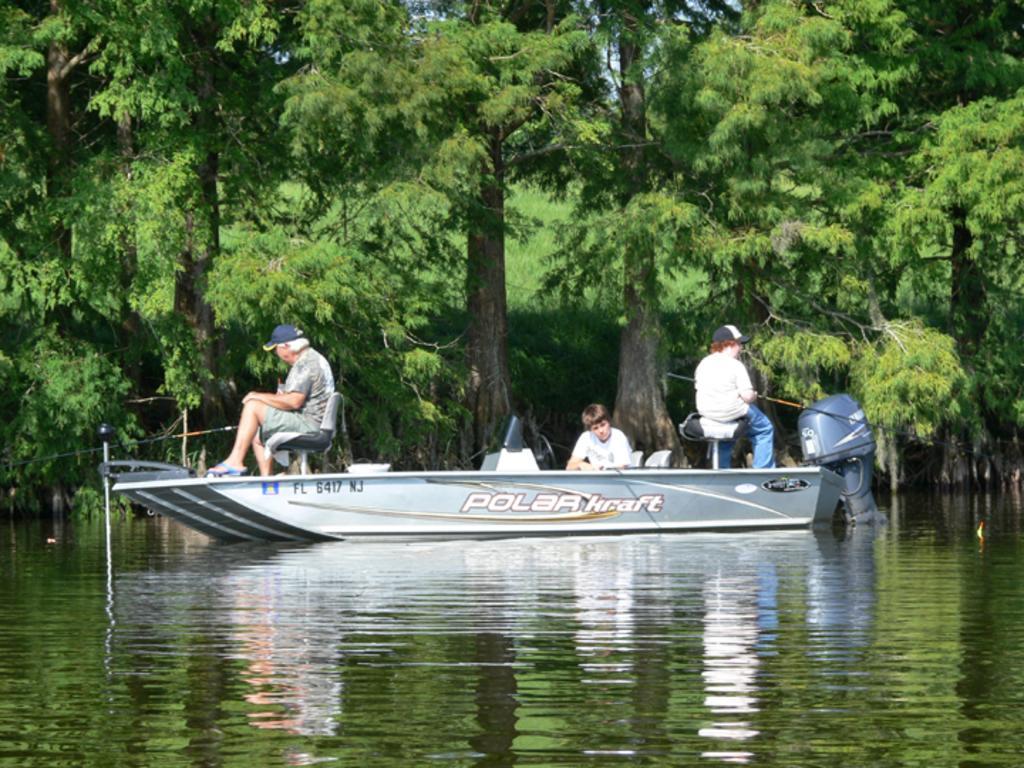In one or two sentences, can you explain what this image depicts? In this image I can see water and in it I can see a boat. I can also see few people are sitting on this boat and here I can see something is written. In the background I can see number of trees and I can see few people are wearing caps. 